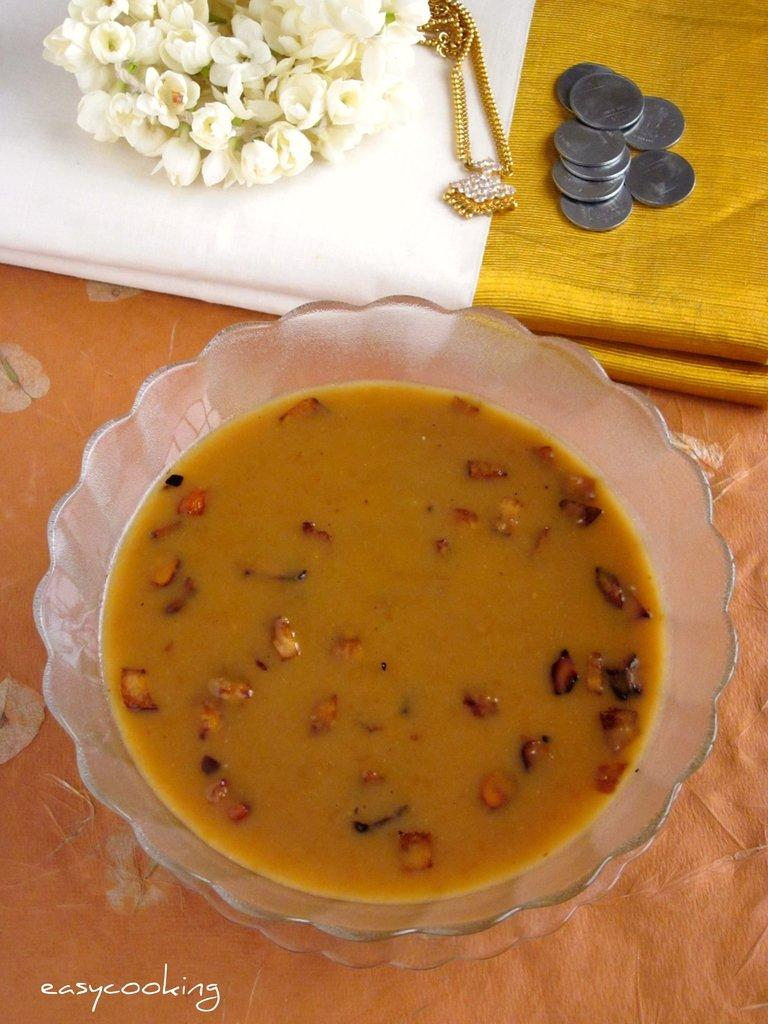What is in the bowl that is visible in the image? There is a bowl with sweet and dry fruits in the image. What type of clothing can be seen in the image? There is a saree in the image. What type of accessories are present in the image? There is jewelry in the image. What type of currency is visible in the image? There are coins in the image. What type of natural elements are present in the image? There are flowers in the image. What type of whistle can be heard in the image? There is no whistle present in the image, and therefore no sound can be heard. What type of scent is emanating from the flowers in the image? The image does not provide information about the scent of the flowers, only their visual appearance. 